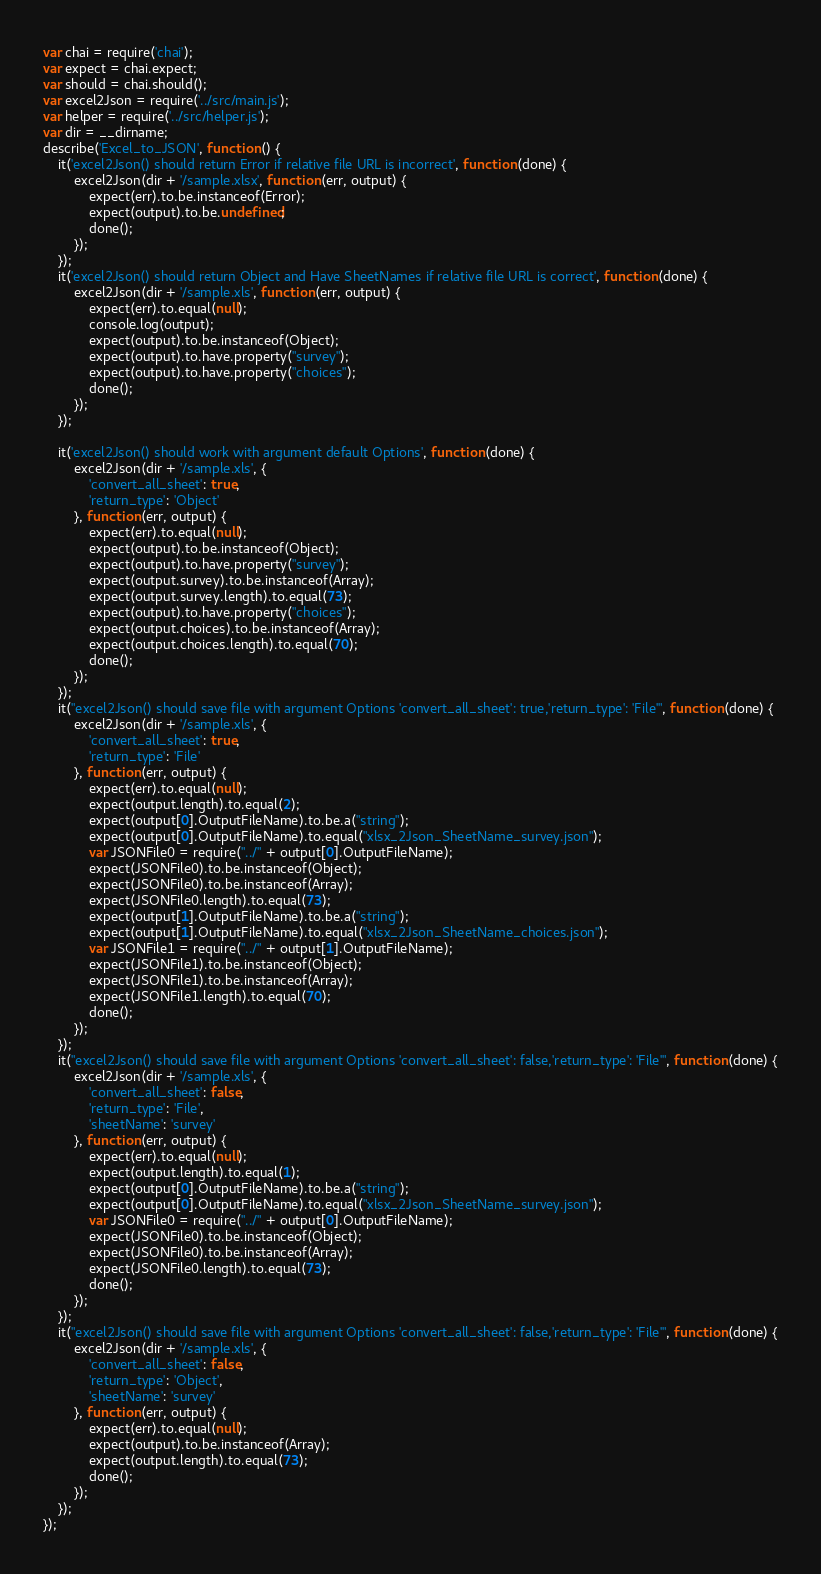<code> <loc_0><loc_0><loc_500><loc_500><_JavaScript_>var chai = require('chai');
var expect = chai.expect;
var should = chai.should();
var excel2Json = require('../src/main.js');
var helper = require('../src/helper.js');
var dir = __dirname;
describe('Excel_to_JSON', function () {
    it('excel2Json() should return Error if relative file URL is incorrect', function (done) {
        excel2Json(dir + '/sample.xlsx', function (err, output) {
            expect(err).to.be.instanceof(Error);
            expect(output).to.be.undefined;
            done();
        });
    });
    it('excel2Json() should return Object and Have SheetNames if relative file URL is correct', function (done) {
        excel2Json(dir + '/sample.xls', function (err, output) {
            expect(err).to.equal(null);
            console.log(output);
            expect(output).to.be.instanceof(Object);
            expect(output).to.have.property("survey");
            expect(output).to.have.property("choices");
            done();
        });
    });

    it('excel2Json() should work with argument default Options', function (done) {
        excel2Json(dir + '/sample.xls', {
            'convert_all_sheet': true,
            'return_type': 'Object'
        }, function (err, output) {
            expect(err).to.equal(null);
            expect(output).to.be.instanceof(Object);
            expect(output).to.have.property("survey");
            expect(output.survey).to.be.instanceof(Array);
            expect(output.survey.length).to.equal(73);
            expect(output).to.have.property("choices");
            expect(output.choices).to.be.instanceof(Array);
            expect(output.choices.length).to.equal(70);
            done();
        });
    });
    it("excel2Json() should save file with argument Options 'convert_all_sheet': true,'return_type': 'File'", function (done) {
        excel2Json(dir + '/sample.xls', {
            'convert_all_sheet': true,
            'return_type': 'File'
        }, function (err, output) {
            expect(err).to.equal(null);
            expect(output.length).to.equal(2);
            expect(output[0].OutputFileName).to.be.a("string");
            expect(output[0].OutputFileName).to.equal("xlsx_2Json_SheetName_survey.json");
            var JSONFile0 = require("../" + output[0].OutputFileName);
            expect(JSONFile0).to.be.instanceof(Object);
            expect(JSONFile0).to.be.instanceof(Array);
            expect(JSONFile0.length).to.equal(73);
            expect(output[1].OutputFileName).to.be.a("string");
            expect(output[1].OutputFileName).to.equal("xlsx_2Json_SheetName_choices.json");
            var JSONFile1 = require("../" + output[1].OutputFileName);
            expect(JSONFile1).to.be.instanceof(Object);
            expect(JSONFile1).to.be.instanceof(Array);
            expect(JSONFile1.length).to.equal(70);
            done();
        });
    });
    it("excel2Json() should save file with argument Options 'convert_all_sheet': false,'return_type': 'File'", function (done) {
        excel2Json(dir + '/sample.xls', {
            'convert_all_sheet': false,
            'return_type': 'File',
            'sheetName': 'survey'
        }, function (err, output) {
            expect(err).to.equal(null);
            expect(output.length).to.equal(1);
            expect(output[0].OutputFileName).to.be.a("string");
            expect(output[0].OutputFileName).to.equal("xlsx_2Json_SheetName_survey.json");
            var JSONFile0 = require("../" + output[0].OutputFileName);
            expect(JSONFile0).to.be.instanceof(Object);
            expect(JSONFile0).to.be.instanceof(Array);
            expect(JSONFile0.length).to.equal(73);
            done();
        });
    });
    it("excel2Json() should save file with argument Options 'convert_all_sheet': false,'return_type': 'File'", function (done) {
        excel2Json(dir + '/sample.xls', {
            'convert_all_sheet': false,
            'return_type': 'Object',
            'sheetName': 'survey'
        }, function (err, output) {
            expect(err).to.equal(null);
            expect(output).to.be.instanceof(Array);
            expect(output.length).to.equal(73);
            done();
        });
    });
});
</code> 